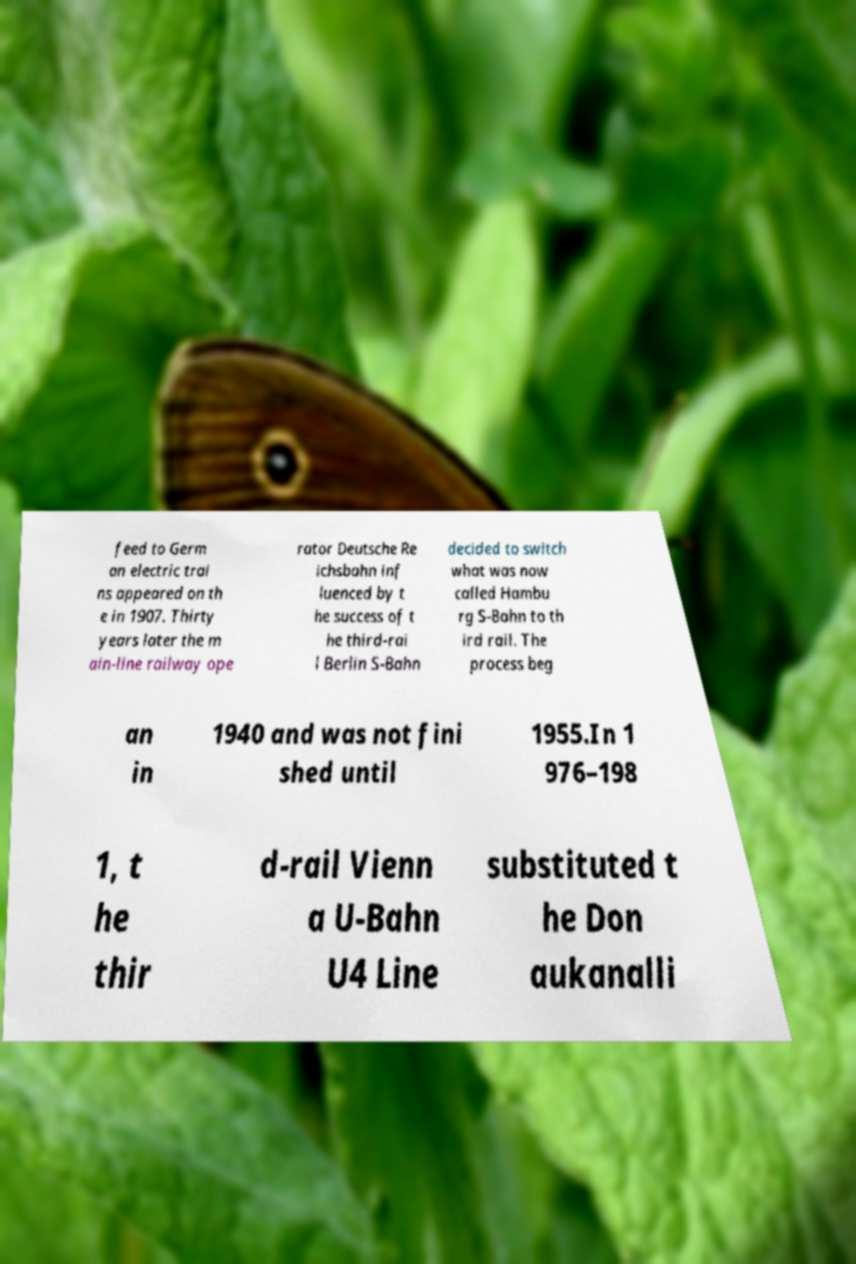I need the written content from this picture converted into text. Can you do that? feed to Germ an electric trai ns appeared on th e in 1907. Thirty years later the m ain-line railway ope rator Deutsche Re ichsbahn inf luenced by t he success of t he third-rai l Berlin S-Bahn decided to switch what was now called Hambu rg S-Bahn to th ird rail. The process beg an in 1940 and was not fini shed until 1955.In 1 976–198 1, t he thir d-rail Vienn a U-Bahn U4 Line substituted t he Don aukanalli 